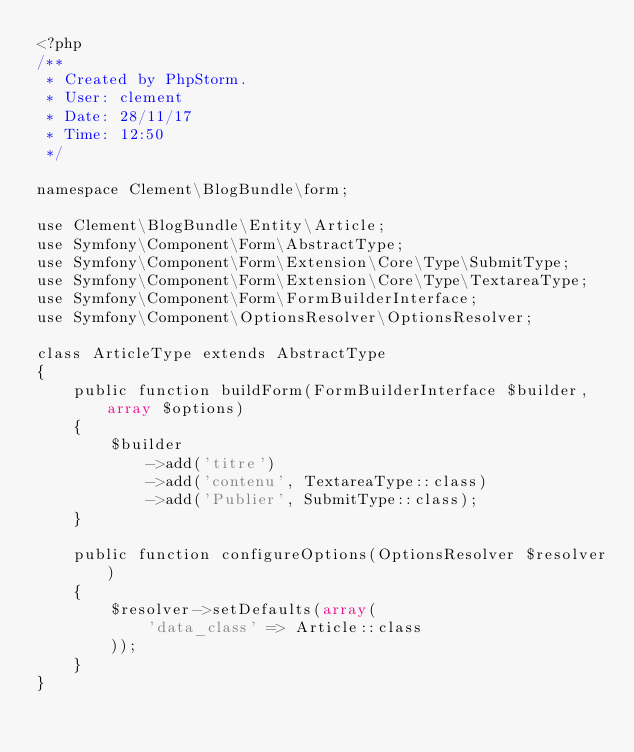Convert code to text. <code><loc_0><loc_0><loc_500><loc_500><_PHP_><?php
/**
 * Created by PhpStorm.
 * User: clement
 * Date: 28/11/17
 * Time: 12:50
 */

namespace Clement\BlogBundle\form;

use Clement\BlogBundle\Entity\Article;
use Symfony\Component\Form\AbstractType;
use Symfony\Component\Form\Extension\Core\Type\SubmitType;
use Symfony\Component\Form\Extension\Core\Type\TextareaType;
use Symfony\Component\Form\FormBuilderInterface;
use Symfony\Component\OptionsResolver\OptionsResolver;

class ArticleType extends AbstractType
{
    public function buildForm(FormBuilderInterface $builder, array $options)
    {
        $builder
            ->add('titre')
            ->add('contenu', TextareaType::class)
            ->add('Publier', SubmitType::class);
    }

    public function configureOptions(OptionsResolver $resolver)
    {
        $resolver->setDefaults(array(
            'data_class' => Article::class
        ));
    }
}</code> 